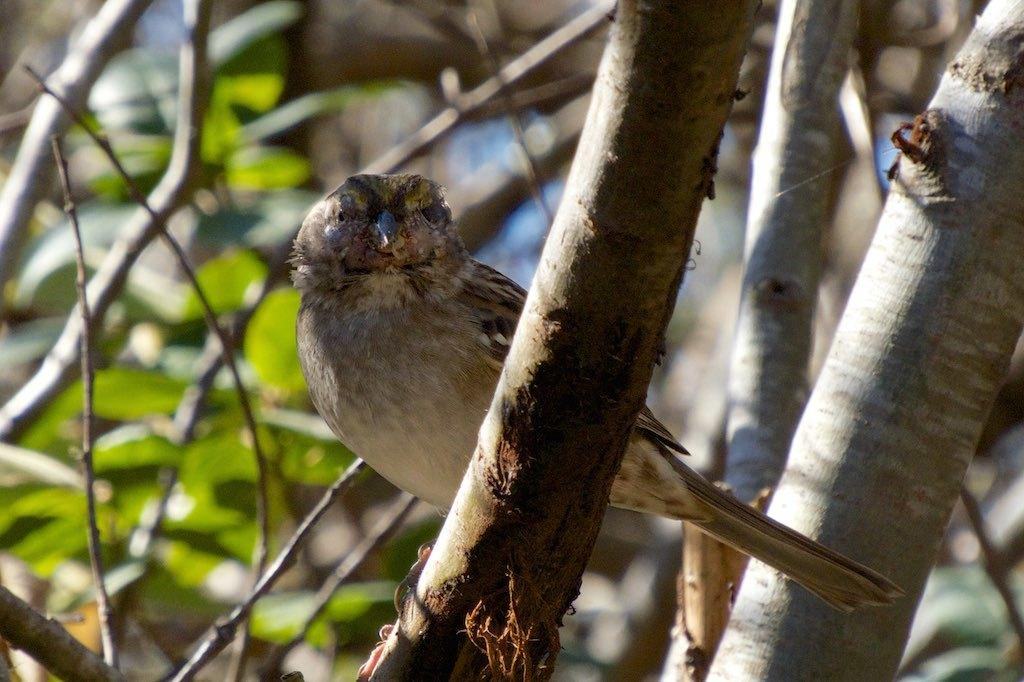What type of animal can be seen in the image? There is a bird in the image. Where is the bird located in the image? The bird is represented on a branch of a tree. What type of leather material can be seen on the bird in the image? There is no leather material present on the bird in the image; it is a bird represented on a branch of a tree. 